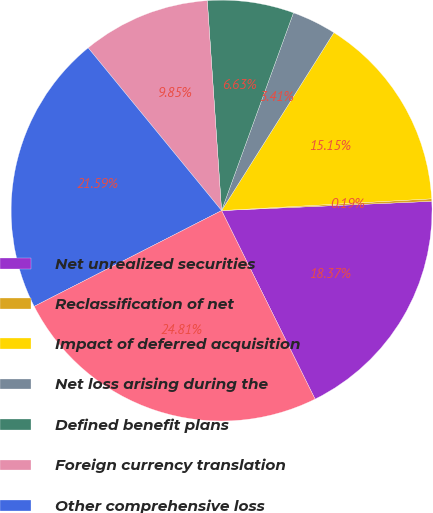Convert chart to OTSL. <chart><loc_0><loc_0><loc_500><loc_500><pie_chart><fcel>Net unrealized securities<fcel>Reclassification of net<fcel>Impact of deferred acquisition<fcel>Net loss arising during the<fcel>Defined benefit plans<fcel>Foreign currency translation<fcel>Other comprehensive loss<fcel>Total other comprehensive loss<nl><fcel>18.37%<fcel>0.19%<fcel>15.15%<fcel>3.41%<fcel>6.63%<fcel>9.85%<fcel>21.59%<fcel>24.81%<nl></chart> 